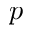<formula> <loc_0><loc_0><loc_500><loc_500>p</formula> 